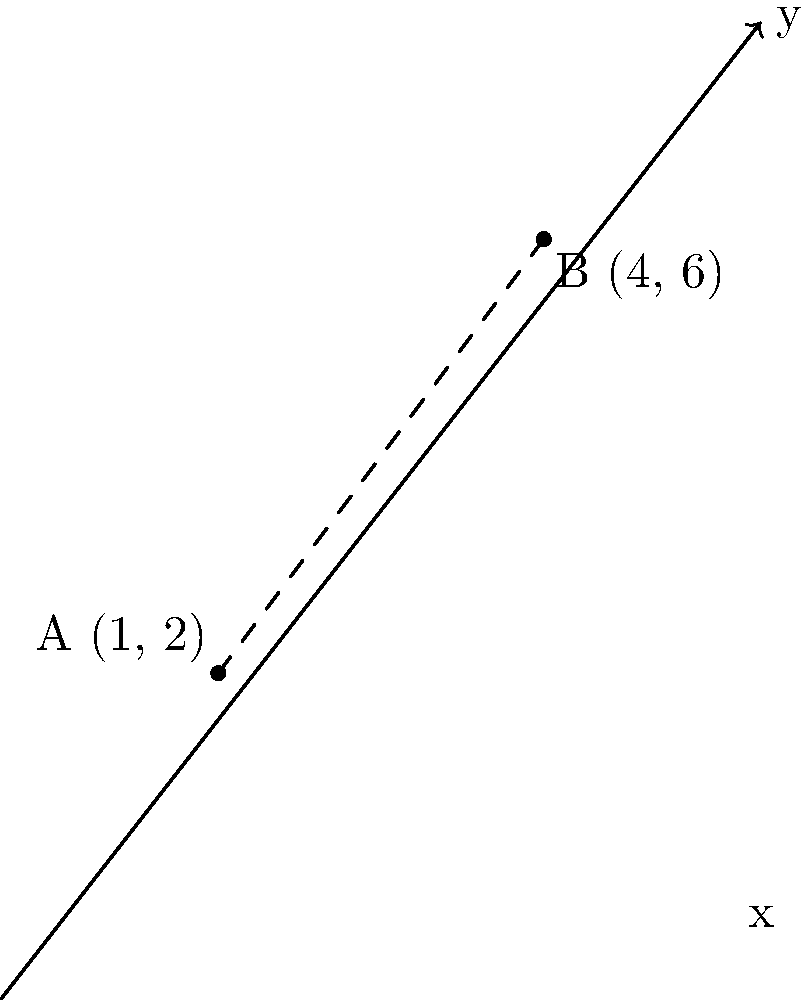Alright, class! Let's spice things up with a line that's anything but straight-laced! We've got two silly points playing hide-and-seek on our coordinate plane: Point A is chilling at (1, 2), while Point B is living it up at (4, 6). Can you find the equation of the line that connects these two party animals? And remember, in geometry, even the most serious lines can have a sense of humor! Let's dive into this geometric giggle-fest, shall we?

Step 1: Calculate the slope (m) of our line using the "rise over run" formula:
$$m = \frac{y_2 - y_1}{x_2 - x_1} = \frac{6 - 2}{4 - 1} = \frac{4}{3}$$

Step 2: Now that we've got our slope, let's use the point-slope form of a line equation. We'll use Point A (1, 2) as our reference point:
$$(y - y_1) = m(x - x_1)$$
$$(y - 2) = \frac{4}{3}(x - 1)$$

Step 3: Let's expand this equation:
$$y - 2 = \frac{4}{3}x - \frac{4}{3}$$

Step 4: Add 2 to both sides to isolate y:
$$y = \frac{4}{3}x - \frac{4}{3} + 2$$

Step 5: Simplify by finding a common denominator:
$$y = \frac{4}{3}x + \frac{2}{3}$$

And there you have it! Our line equation is ready to party!
Answer: $y = \frac{4}{3}x + \frac{2}{3}$ 